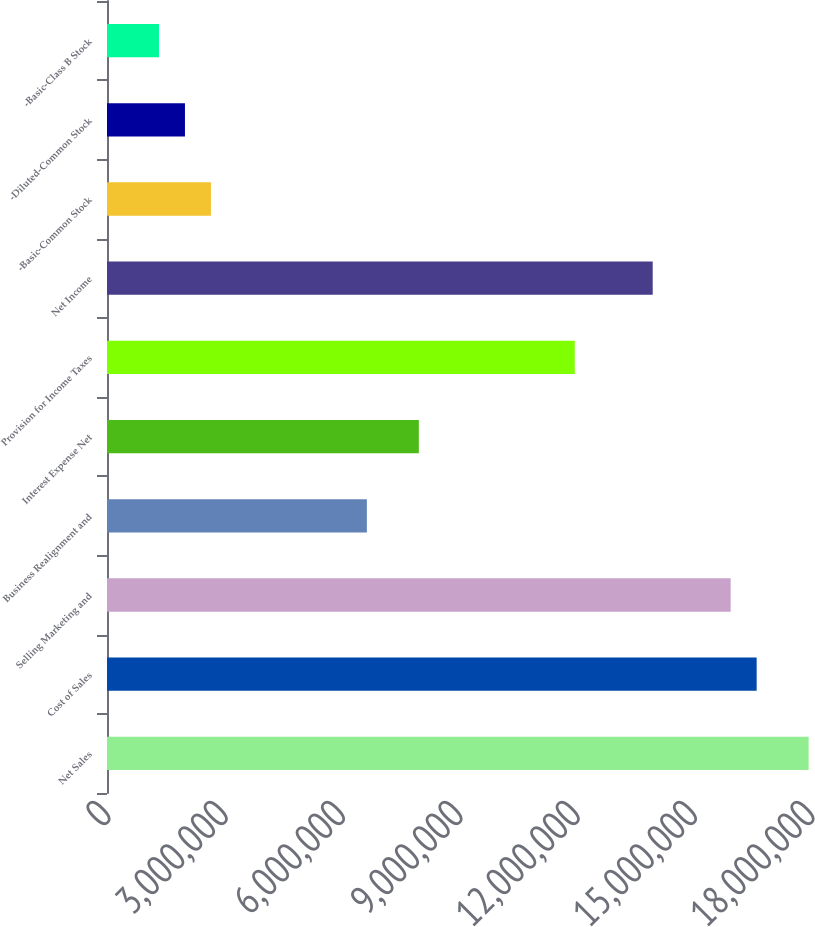Convert chart to OTSL. <chart><loc_0><loc_0><loc_500><loc_500><bar_chart><fcel>Net Sales<fcel>Cost of Sales<fcel>Selling Marketing and<fcel>Business Realignment and<fcel>Interest Expense Net<fcel>Provision for Income Taxes<fcel>Net Income<fcel>-Basic-Common Stock<fcel>-Diluted-Common Stock<fcel>-Basic-Class B Stock<nl><fcel>1.79395e+07<fcel>1.66106e+07<fcel>1.59462e+07<fcel>6.64425e+06<fcel>7.9731e+06<fcel>1.19597e+07<fcel>1.39529e+07<fcel>2.6577e+06<fcel>1.99328e+06<fcel>1.32885e+06<nl></chart> 